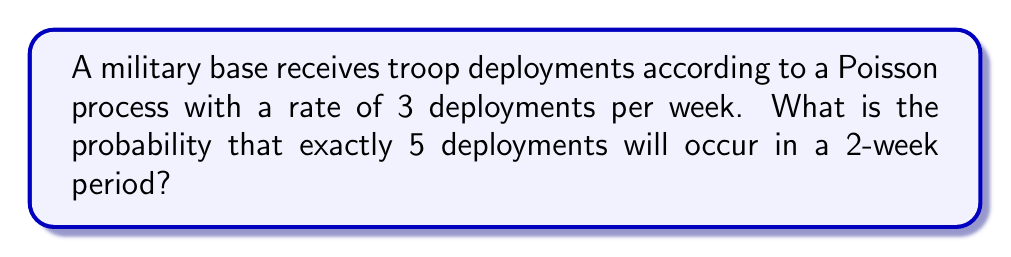Teach me how to tackle this problem. Let's approach this step-by-step:

1) We are dealing with a Poisson process, where:
   - The rate (λ) is 3 deployments per week
   - The time period (t) is 2 weeks
   - We want the probability of exactly 5 deployments (k = 5)

2) For a Poisson process, the number of events in a fixed time interval follows a Poisson distribution. The probability mass function for a Poisson distribution is:

   $$P(X = k) = \frac{e^{-λt}(λt)^k}{k!}$$

3) We need to calculate λt:
   λt = 3 deployments/week × 2 weeks = 6 deployments

4) Now we can plug our values into the formula:

   $$P(X = 5) = \frac{e^{-6}(6)^5}{5!}$$

5) Let's calculate this step-by-step:
   - $6^5 = 7776$
   - $5! = 5 × 4 × 3 × 2 × 1 = 120$
   - $e^{-6} ≈ 0.00247875$

6) Putting it all together:

   $$P(X = 5) = \frac{0.00247875 × 7776}{120} ≈ 0.16062$$

7) Therefore, the probability of exactly 5 deployments in a 2-week period is approximately 0.16062 or 16.062%.
Answer: 0.16062 